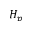<formula> <loc_0><loc_0><loc_500><loc_500>H _ { p }</formula> 